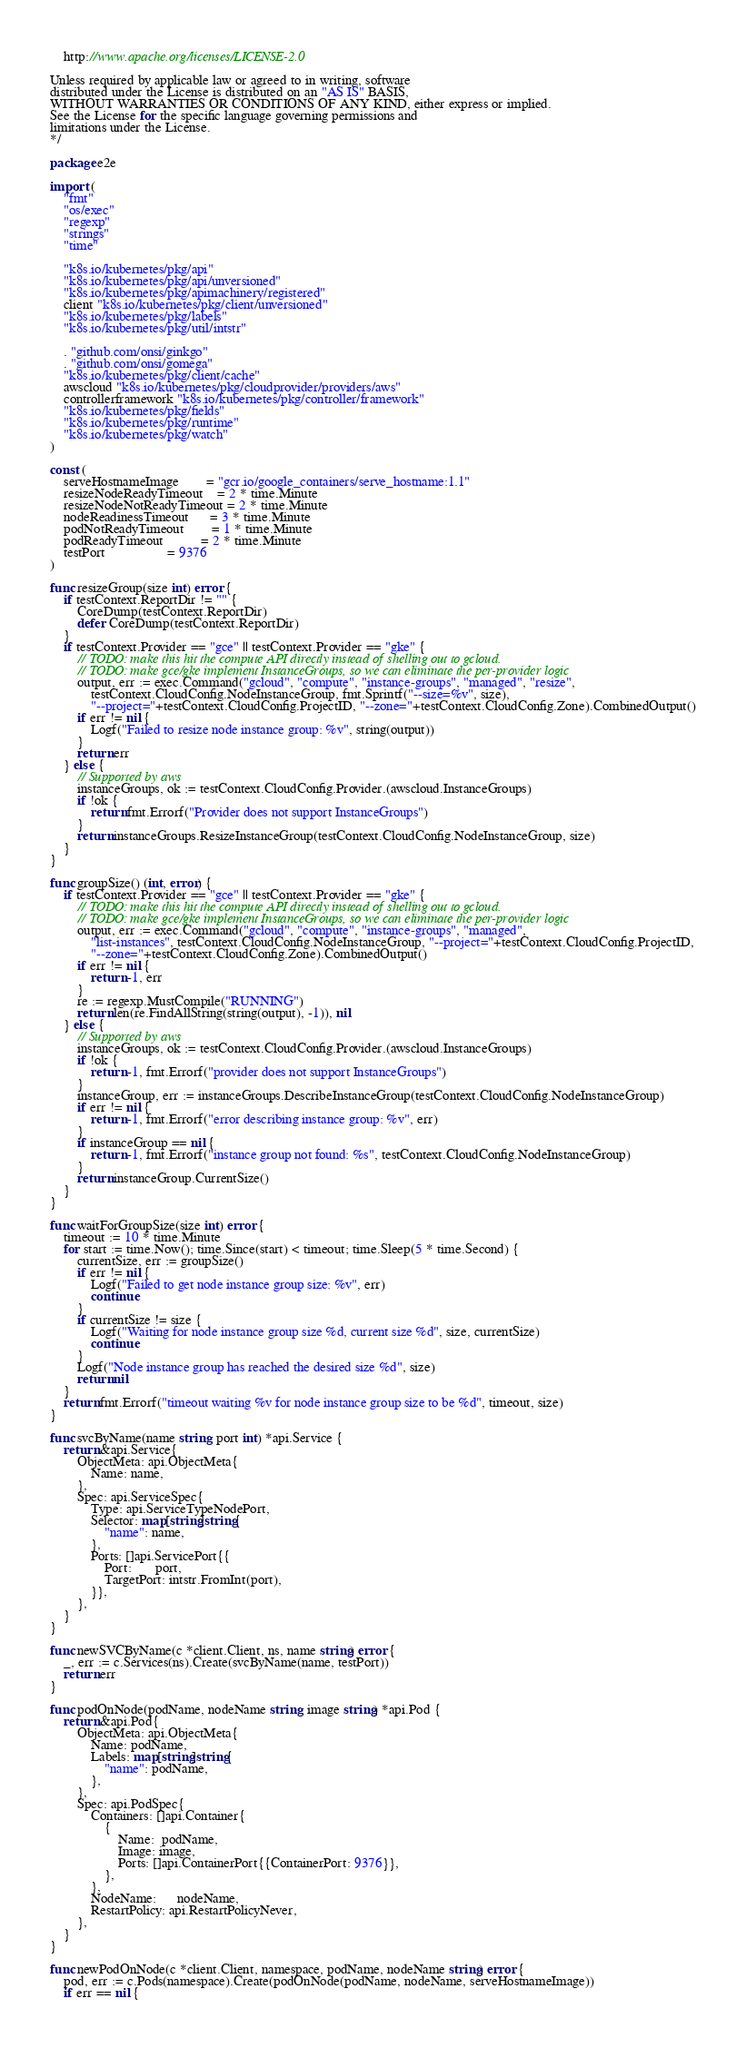Convert code to text. <code><loc_0><loc_0><loc_500><loc_500><_Go_>
    http://www.apache.org/licenses/LICENSE-2.0

Unless required by applicable law or agreed to in writing, software
distributed under the License is distributed on an "AS IS" BASIS,
WITHOUT WARRANTIES OR CONDITIONS OF ANY KIND, either express or implied.
See the License for the specific language governing permissions and
limitations under the License.
*/

package e2e

import (
	"fmt"
	"os/exec"
	"regexp"
	"strings"
	"time"

	"k8s.io/kubernetes/pkg/api"
	"k8s.io/kubernetes/pkg/api/unversioned"
	"k8s.io/kubernetes/pkg/apimachinery/registered"
	client "k8s.io/kubernetes/pkg/client/unversioned"
	"k8s.io/kubernetes/pkg/labels"
	"k8s.io/kubernetes/pkg/util/intstr"

	. "github.com/onsi/ginkgo"
	. "github.com/onsi/gomega"
	"k8s.io/kubernetes/pkg/client/cache"
	awscloud "k8s.io/kubernetes/pkg/cloudprovider/providers/aws"
	controllerframework "k8s.io/kubernetes/pkg/controller/framework"
	"k8s.io/kubernetes/pkg/fields"
	"k8s.io/kubernetes/pkg/runtime"
	"k8s.io/kubernetes/pkg/watch"
)

const (
	serveHostnameImage        = "gcr.io/google_containers/serve_hostname:1.1"
	resizeNodeReadyTimeout    = 2 * time.Minute
	resizeNodeNotReadyTimeout = 2 * time.Minute
	nodeReadinessTimeout      = 3 * time.Minute
	podNotReadyTimeout        = 1 * time.Minute
	podReadyTimeout           = 2 * time.Minute
	testPort                  = 9376
)

func resizeGroup(size int) error {
	if testContext.ReportDir != "" {
		CoreDump(testContext.ReportDir)
		defer CoreDump(testContext.ReportDir)
	}
	if testContext.Provider == "gce" || testContext.Provider == "gke" {
		// TODO: make this hit the compute API directly instead of shelling out to gcloud.
		// TODO: make gce/gke implement InstanceGroups, so we can eliminate the per-provider logic
		output, err := exec.Command("gcloud", "compute", "instance-groups", "managed", "resize",
			testContext.CloudConfig.NodeInstanceGroup, fmt.Sprintf("--size=%v", size),
			"--project="+testContext.CloudConfig.ProjectID, "--zone="+testContext.CloudConfig.Zone).CombinedOutput()
		if err != nil {
			Logf("Failed to resize node instance group: %v", string(output))
		}
		return err
	} else {
		// Supported by aws
		instanceGroups, ok := testContext.CloudConfig.Provider.(awscloud.InstanceGroups)
		if !ok {
			return fmt.Errorf("Provider does not support InstanceGroups")
		}
		return instanceGroups.ResizeInstanceGroup(testContext.CloudConfig.NodeInstanceGroup, size)
	}
}

func groupSize() (int, error) {
	if testContext.Provider == "gce" || testContext.Provider == "gke" {
		// TODO: make this hit the compute API directly instead of shelling out to gcloud.
		// TODO: make gce/gke implement InstanceGroups, so we can eliminate the per-provider logic
		output, err := exec.Command("gcloud", "compute", "instance-groups", "managed",
			"list-instances", testContext.CloudConfig.NodeInstanceGroup, "--project="+testContext.CloudConfig.ProjectID,
			"--zone="+testContext.CloudConfig.Zone).CombinedOutput()
		if err != nil {
			return -1, err
		}
		re := regexp.MustCompile("RUNNING")
		return len(re.FindAllString(string(output), -1)), nil
	} else {
		// Supported by aws
		instanceGroups, ok := testContext.CloudConfig.Provider.(awscloud.InstanceGroups)
		if !ok {
			return -1, fmt.Errorf("provider does not support InstanceGroups")
		}
		instanceGroup, err := instanceGroups.DescribeInstanceGroup(testContext.CloudConfig.NodeInstanceGroup)
		if err != nil {
			return -1, fmt.Errorf("error describing instance group: %v", err)
		}
		if instanceGroup == nil {
			return -1, fmt.Errorf("instance group not found: %s", testContext.CloudConfig.NodeInstanceGroup)
		}
		return instanceGroup.CurrentSize()
	}
}

func waitForGroupSize(size int) error {
	timeout := 10 * time.Minute
	for start := time.Now(); time.Since(start) < timeout; time.Sleep(5 * time.Second) {
		currentSize, err := groupSize()
		if err != nil {
			Logf("Failed to get node instance group size: %v", err)
			continue
		}
		if currentSize != size {
			Logf("Waiting for node instance group size %d, current size %d", size, currentSize)
			continue
		}
		Logf("Node instance group has reached the desired size %d", size)
		return nil
	}
	return fmt.Errorf("timeout waiting %v for node instance group size to be %d", timeout, size)
}

func svcByName(name string, port int) *api.Service {
	return &api.Service{
		ObjectMeta: api.ObjectMeta{
			Name: name,
		},
		Spec: api.ServiceSpec{
			Type: api.ServiceTypeNodePort,
			Selector: map[string]string{
				"name": name,
			},
			Ports: []api.ServicePort{{
				Port:       port,
				TargetPort: intstr.FromInt(port),
			}},
		},
	}
}

func newSVCByName(c *client.Client, ns, name string) error {
	_, err := c.Services(ns).Create(svcByName(name, testPort))
	return err
}

func podOnNode(podName, nodeName string, image string) *api.Pod {
	return &api.Pod{
		ObjectMeta: api.ObjectMeta{
			Name: podName,
			Labels: map[string]string{
				"name": podName,
			},
		},
		Spec: api.PodSpec{
			Containers: []api.Container{
				{
					Name:  podName,
					Image: image,
					Ports: []api.ContainerPort{{ContainerPort: 9376}},
				},
			},
			NodeName:      nodeName,
			RestartPolicy: api.RestartPolicyNever,
		},
	}
}

func newPodOnNode(c *client.Client, namespace, podName, nodeName string) error {
	pod, err := c.Pods(namespace).Create(podOnNode(podName, nodeName, serveHostnameImage))
	if err == nil {</code> 